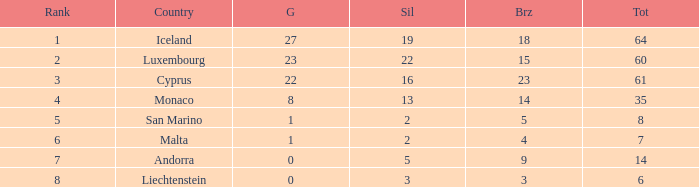How many bronzes for nations with over 22 golds and ranked under 2? 18.0. 